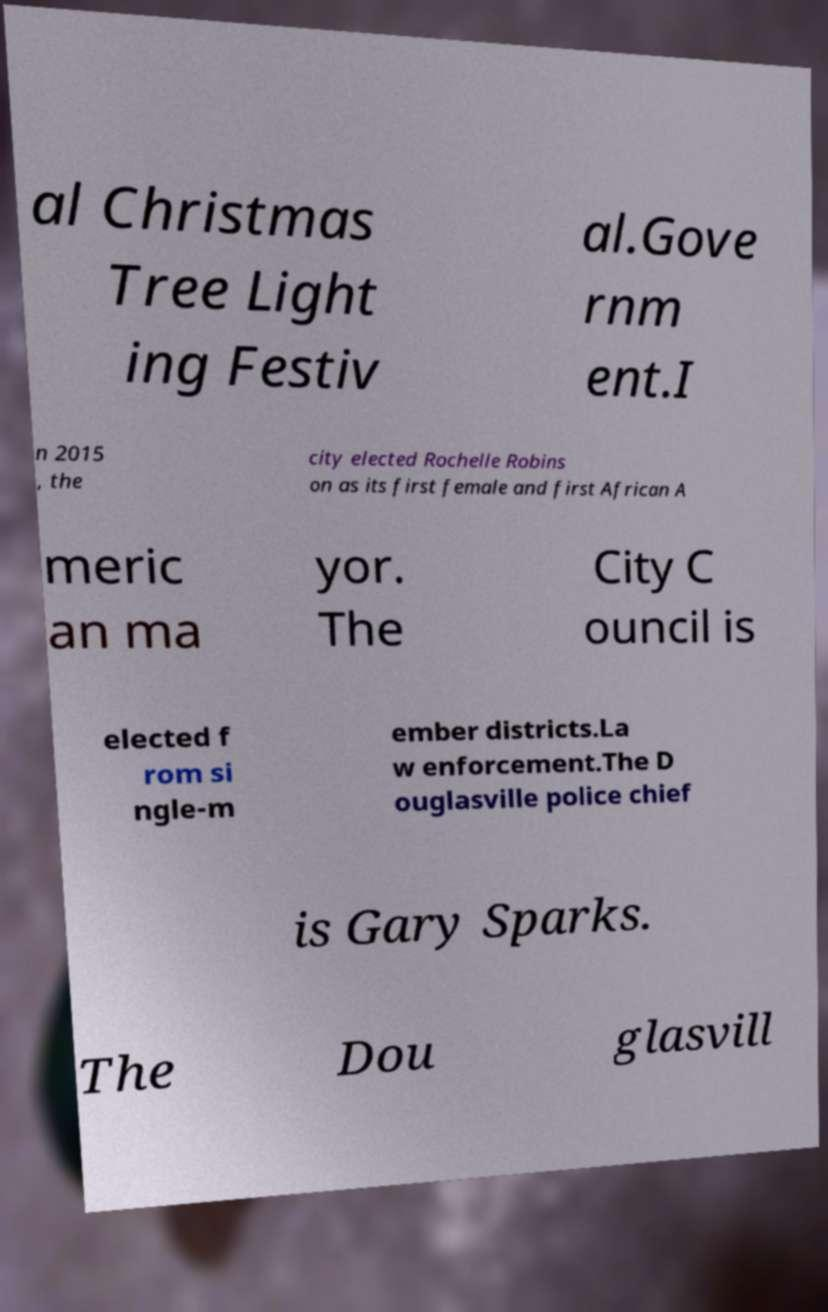Please identify and transcribe the text found in this image. al Christmas Tree Light ing Festiv al.Gove rnm ent.I n 2015 , the city elected Rochelle Robins on as its first female and first African A meric an ma yor. The City C ouncil is elected f rom si ngle-m ember districts.La w enforcement.The D ouglasville police chief is Gary Sparks. The Dou glasvill 